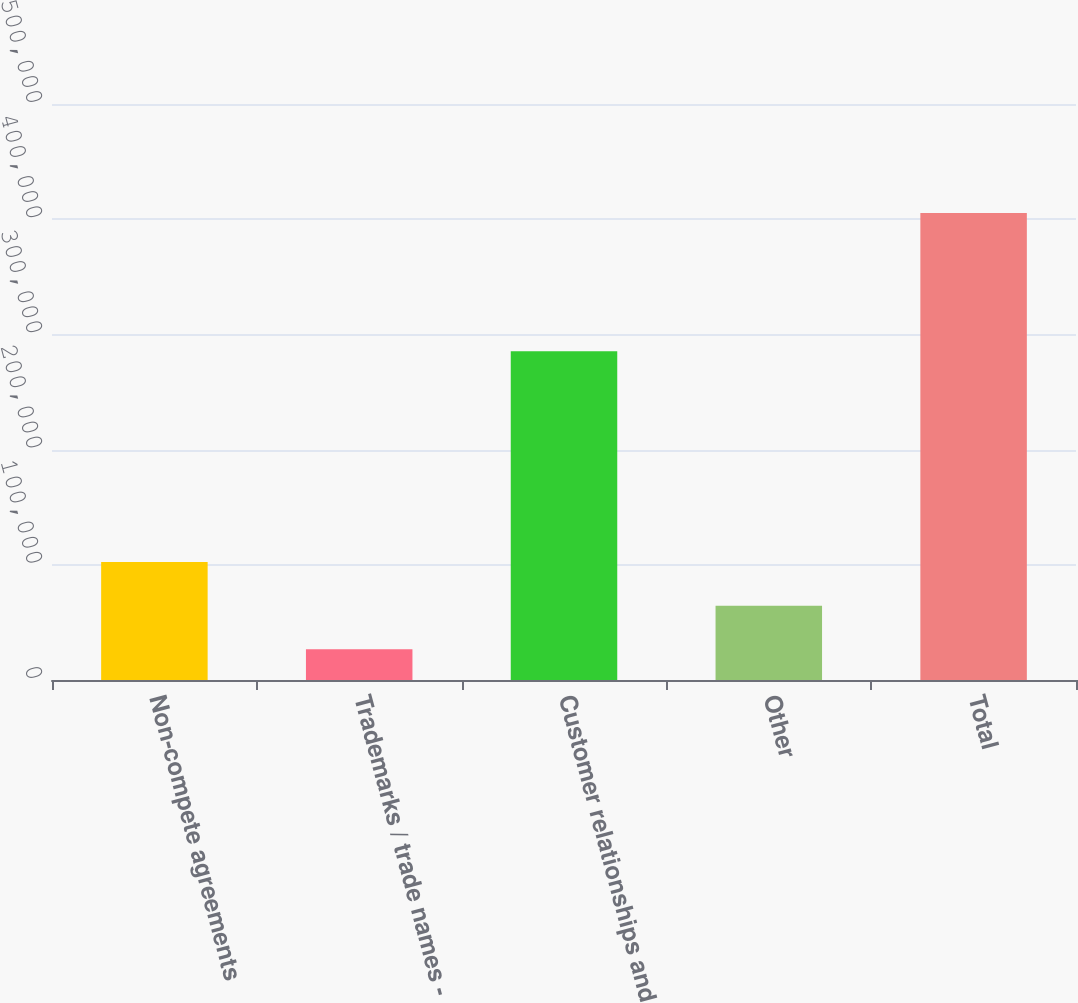<chart> <loc_0><loc_0><loc_500><loc_500><bar_chart><fcel>Non-compete agreements<fcel>Trademarks / trade names -<fcel>Customer relationships and<fcel>Other<fcel>Total<nl><fcel>102438<fcel>26680<fcel>285459<fcel>64558.8<fcel>405468<nl></chart> 